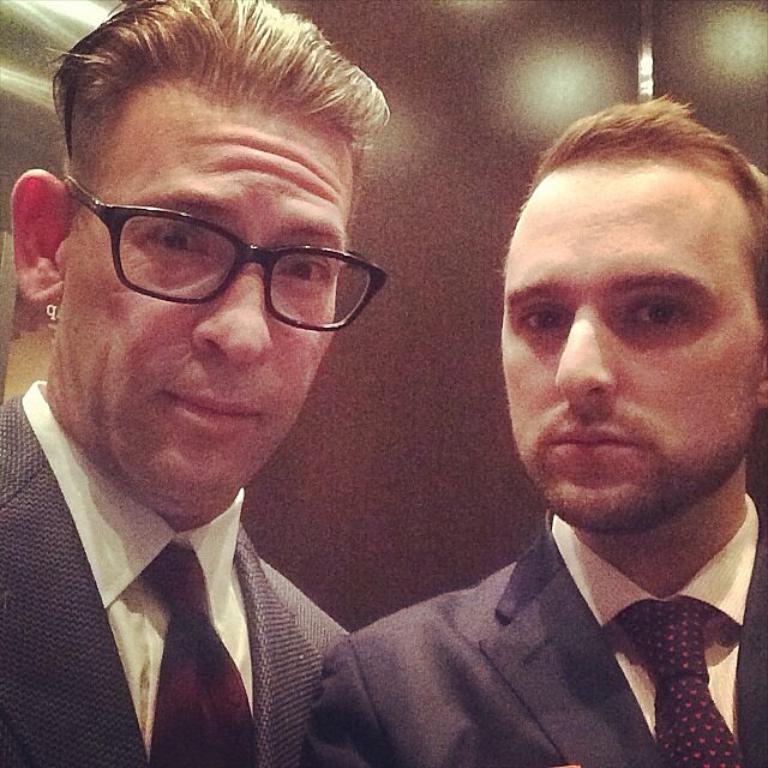Describe this image in one or two sentences. This picture might be taken inside the room. In this image, we can see two men wearing black color suit. 